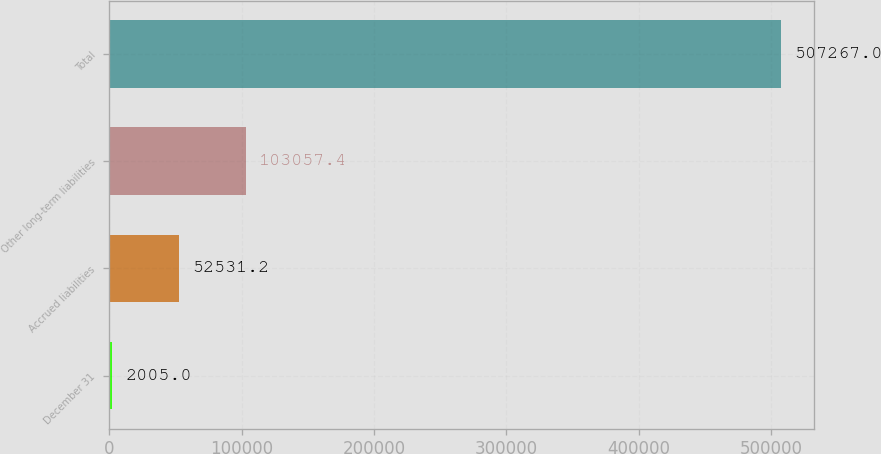Convert chart. <chart><loc_0><loc_0><loc_500><loc_500><bar_chart><fcel>December 31<fcel>Accrued liabilities<fcel>Other long-term liabilities<fcel>Total<nl><fcel>2005<fcel>52531.2<fcel>103057<fcel>507267<nl></chart> 